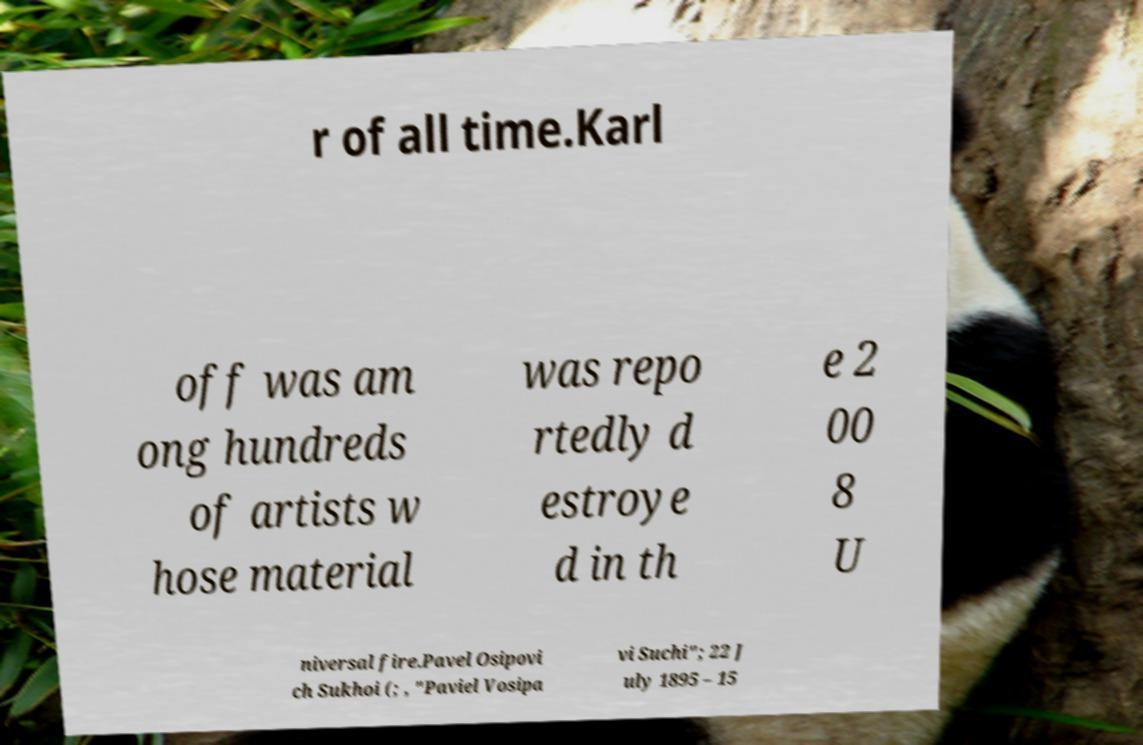For documentation purposes, I need the text within this image transcribed. Could you provide that? r of all time.Karl off was am ong hundreds of artists w hose material was repo rtedly d estroye d in th e 2 00 8 U niversal fire.Pavel Osipovi ch Sukhoi (; , "Paviel Vosipa vi Suchi"; 22 J uly 1895 – 15 